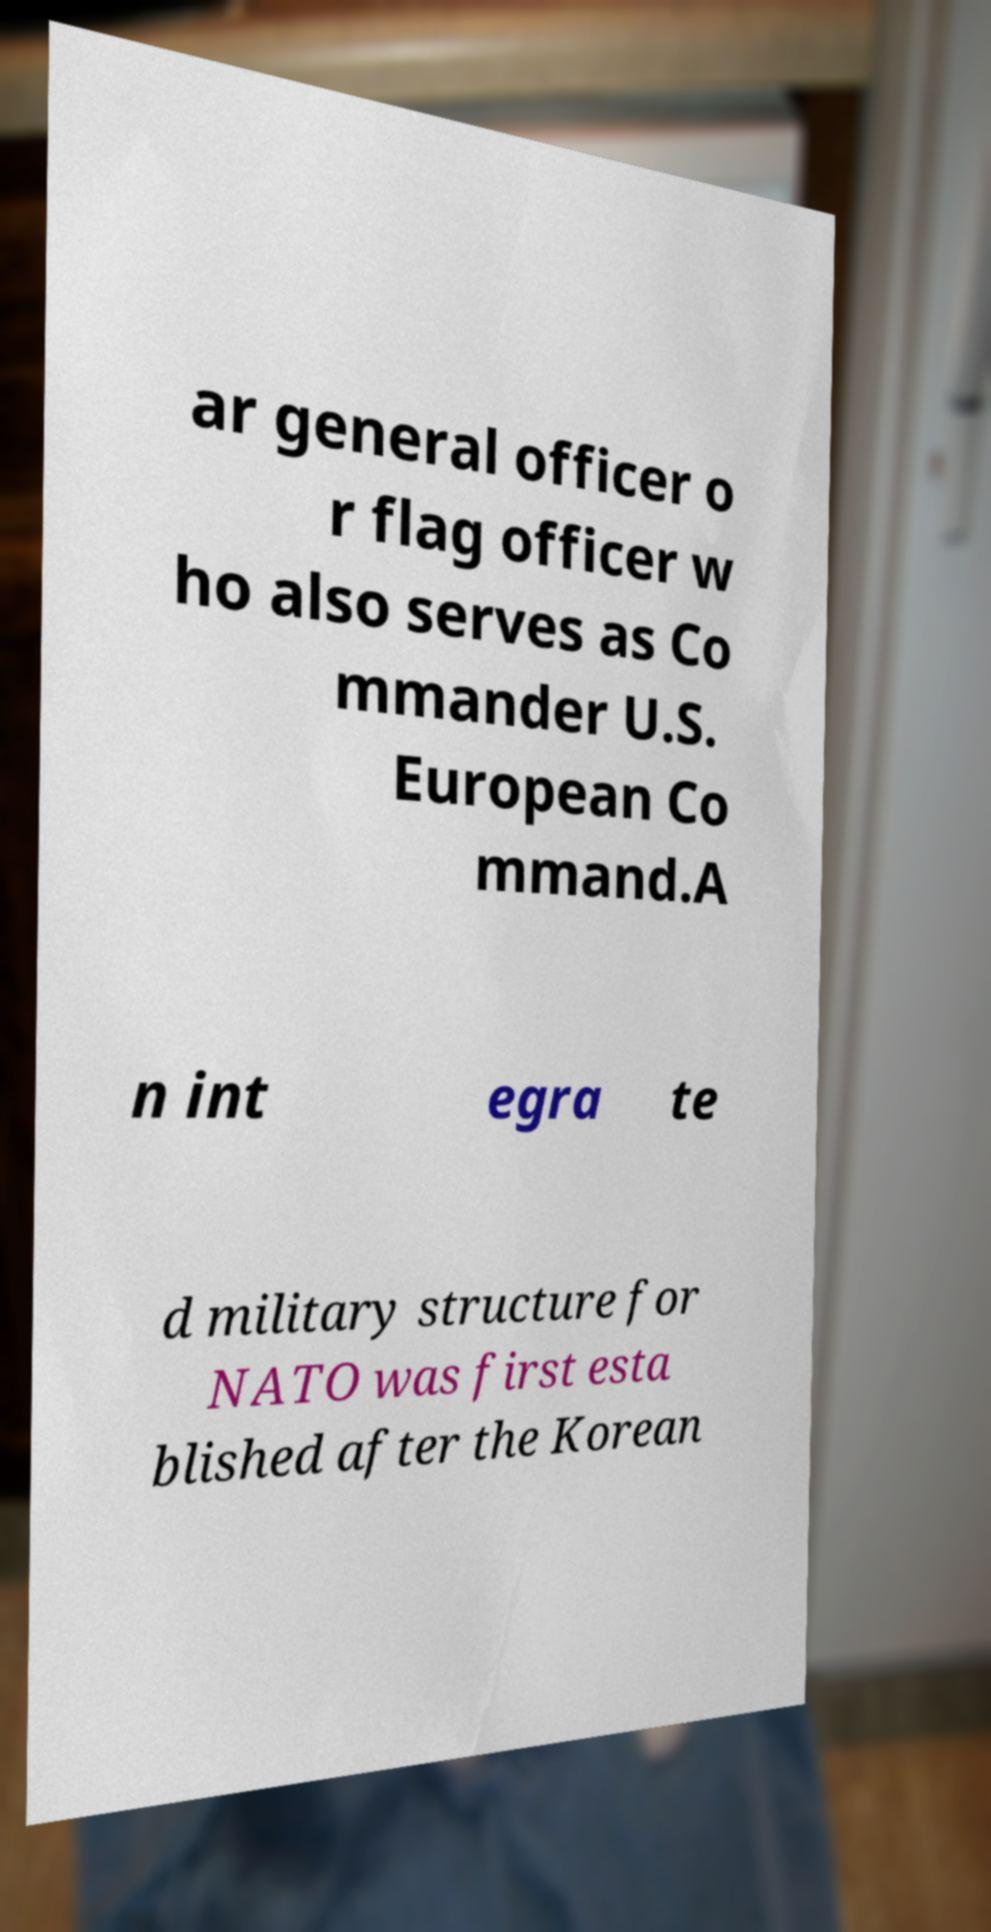Could you extract and type out the text from this image? ar general officer o r flag officer w ho also serves as Co mmander U.S. European Co mmand.A n int egra te d military structure for NATO was first esta blished after the Korean 